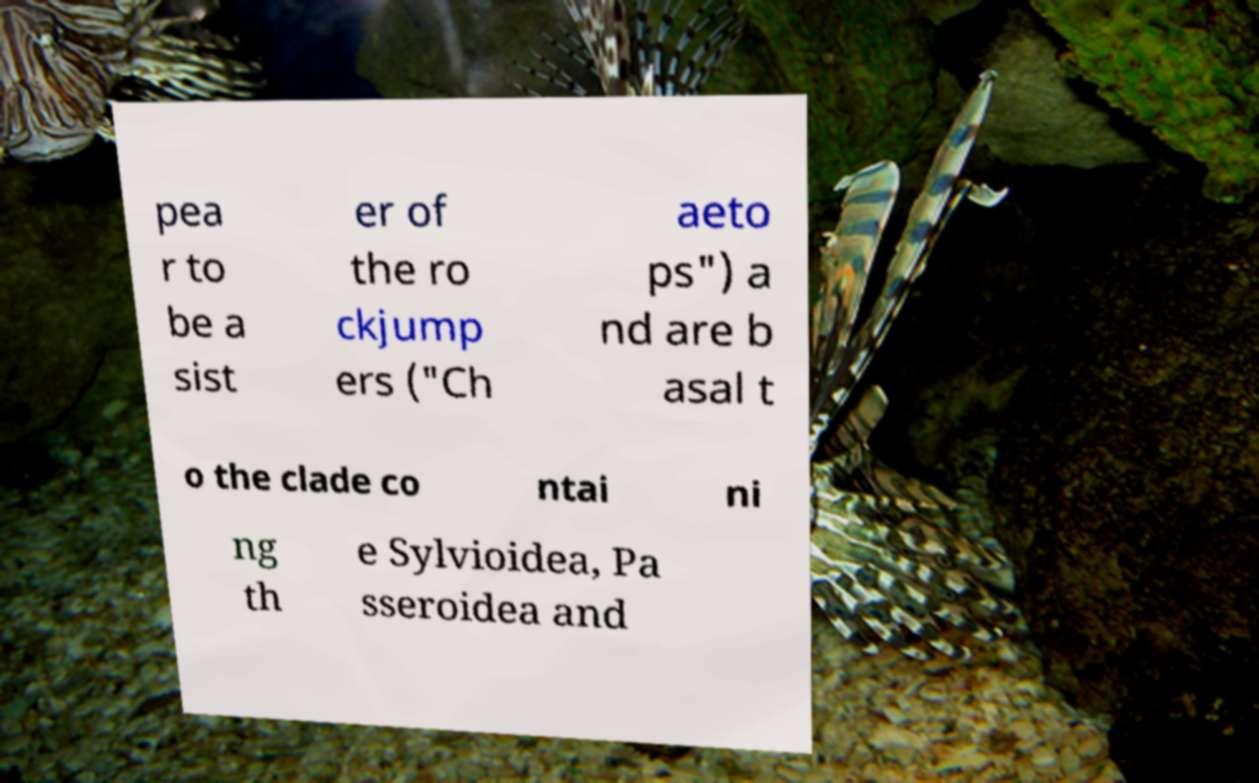Could you extract and type out the text from this image? pea r to be a sist er of the ro ckjump ers ("Ch aeto ps") a nd are b asal t o the clade co ntai ni ng th e Sylvioidea, Pa sseroidea and 